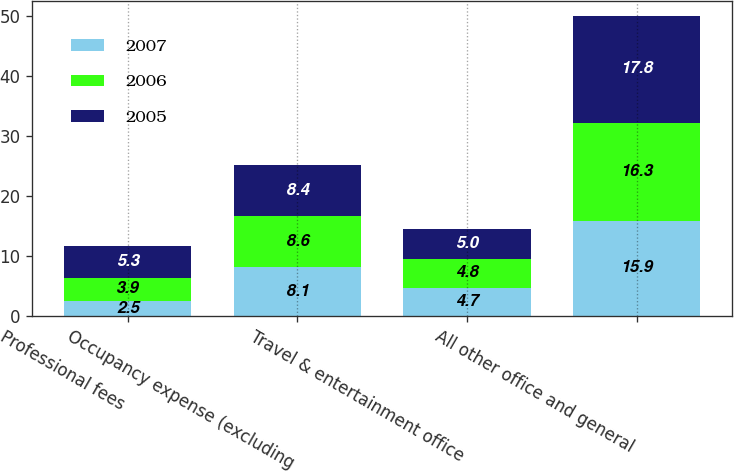Convert chart to OTSL. <chart><loc_0><loc_0><loc_500><loc_500><stacked_bar_chart><ecel><fcel>Professional fees<fcel>Occupancy expense (excluding<fcel>Travel & entertainment office<fcel>All other office and general<nl><fcel>2007<fcel>2.5<fcel>8.1<fcel>4.7<fcel>15.9<nl><fcel>2006<fcel>3.9<fcel>8.6<fcel>4.8<fcel>16.3<nl><fcel>2005<fcel>5.3<fcel>8.4<fcel>5<fcel>17.8<nl></chart> 